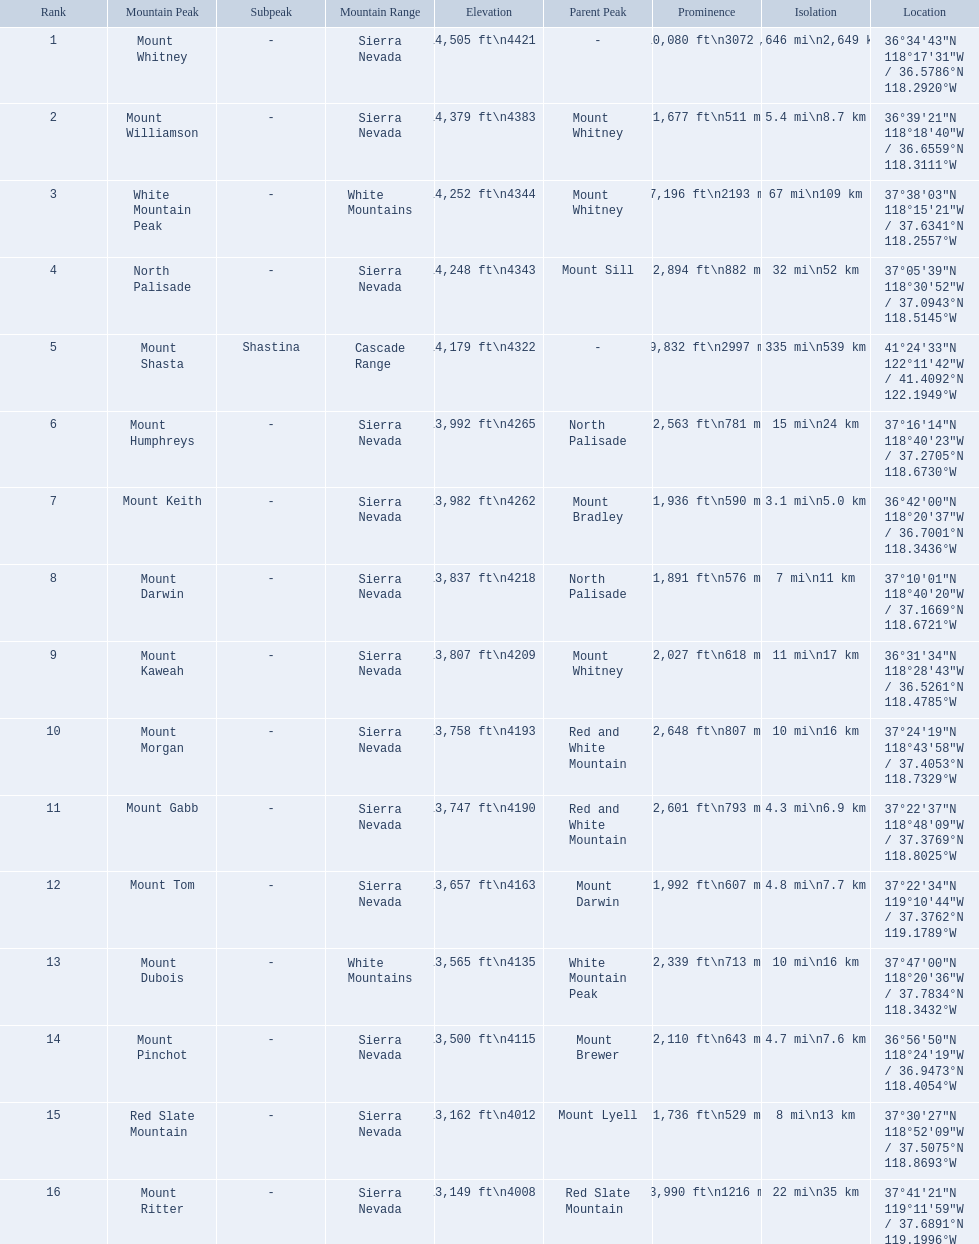What are the mountain peaks? Mount Whitney, Mount Williamson, White Mountain Peak, North Palisade, Mount Shasta, Mount Humphreys, Mount Keith, Mount Darwin, Mount Kaweah, Mount Morgan, Mount Gabb, Mount Tom, Mount Dubois, Mount Pinchot, Red Slate Mountain, Mount Ritter. Of these, which one has a prominence more than 10,000 ft? Mount Whitney. 